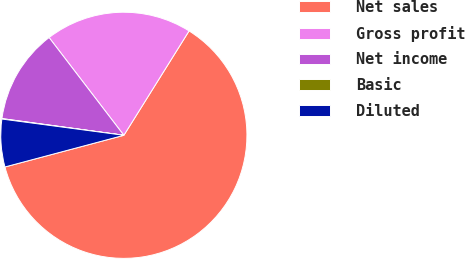Convert chart to OTSL. <chart><loc_0><loc_0><loc_500><loc_500><pie_chart><fcel>Net sales<fcel>Gross profit<fcel>Net income<fcel>Basic<fcel>Diluted<nl><fcel>61.97%<fcel>19.28%<fcel>12.44%<fcel>0.06%<fcel>6.25%<nl></chart> 